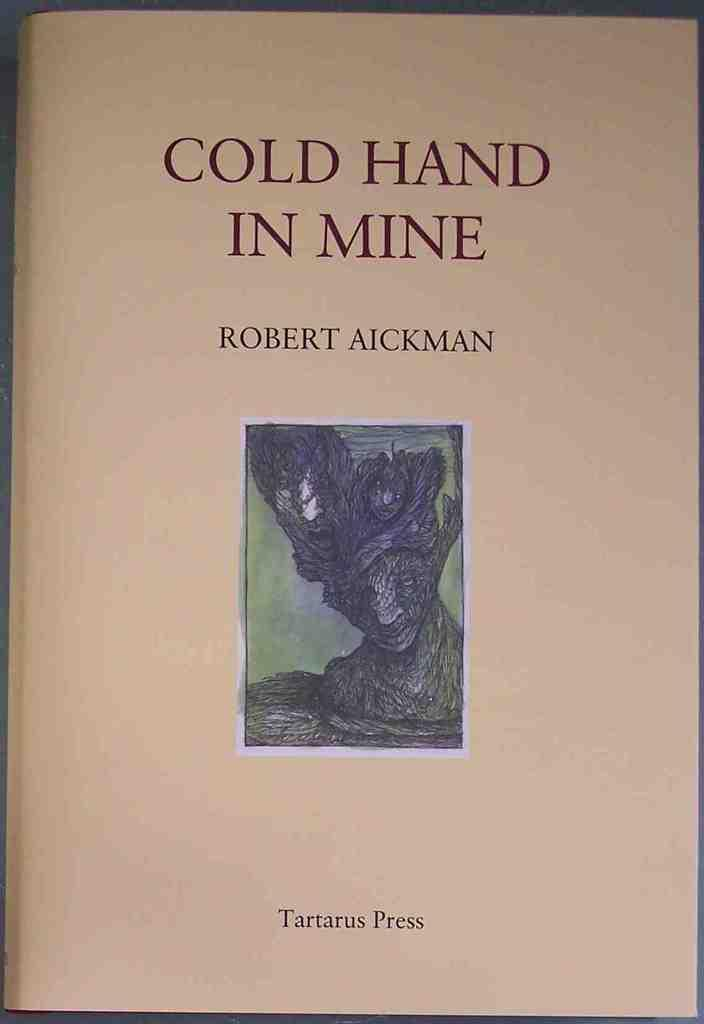<image>
Provide a brief description of the given image. A book by Robert Aickman was published by Tartarus Press. 